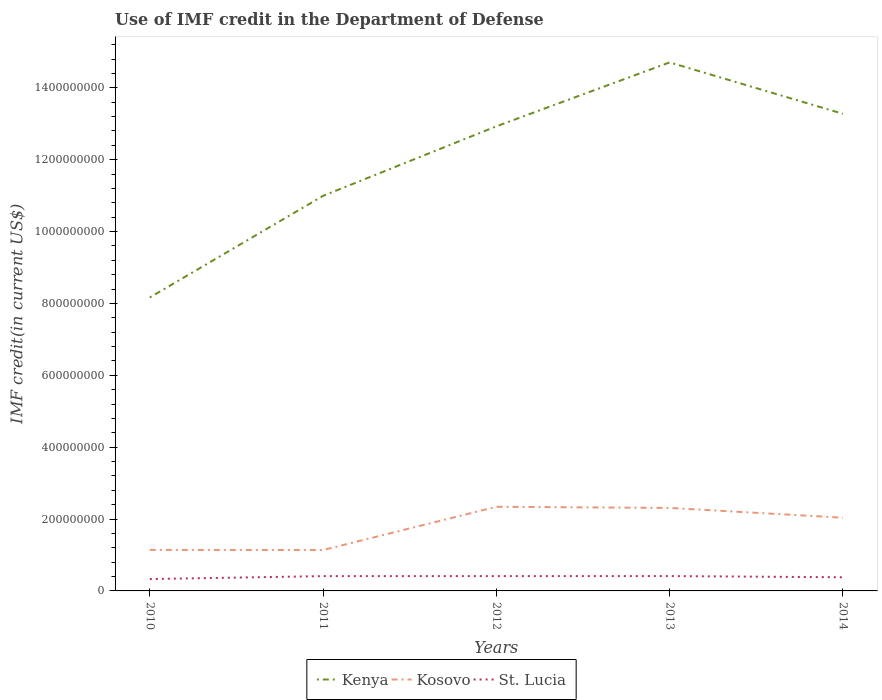How many different coloured lines are there?
Ensure brevity in your answer.  3. Is the number of lines equal to the number of legend labels?
Offer a terse response. Yes. Across all years, what is the maximum IMF credit in the Department of Defense in St. Lucia?
Provide a short and direct response. 3.30e+07. What is the total IMF credit in the Department of Defense in St. Lucia in the graph?
Give a very brief answer. 3.15e+06. What is the difference between the highest and the second highest IMF credit in the Department of Defense in St. Lucia?
Offer a very short reply. 8.25e+06. How many years are there in the graph?
Your answer should be very brief. 5. Does the graph contain any zero values?
Provide a succinct answer. No. Does the graph contain grids?
Ensure brevity in your answer.  No. What is the title of the graph?
Your answer should be compact. Use of IMF credit in the Department of Defense. Does "Samoa" appear as one of the legend labels in the graph?
Make the answer very short. No. What is the label or title of the Y-axis?
Provide a short and direct response. IMF credit(in current US$). What is the IMF credit(in current US$) in Kenya in 2010?
Keep it short and to the point. 8.17e+08. What is the IMF credit(in current US$) of Kosovo in 2010?
Your response must be concise. 1.14e+08. What is the IMF credit(in current US$) in St. Lucia in 2010?
Your answer should be compact. 3.30e+07. What is the IMF credit(in current US$) in Kenya in 2011?
Offer a very short reply. 1.10e+09. What is the IMF credit(in current US$) in Kosovo in 2011?
Make the answer very short. 1.14e+08. What is the IMF credit(in current US$) of St. Lucia in 2011?
Ensure brevity in your answer.  4.12e+07. What is the IMF credit(in current US$) in Kenya in 2012?
Give a very brief answer. 1.29e+09. What is the IMF credit(in current US$) in Kosovo in 2012?
Provide a short and direct response. 2.34e+08. What is the IMF credit(in current US$) in St. Lucia in 2012?
Offer a very short reply. 4.12e+07. What is the IMF credit(in current US$) of Kenya in 2013?
Provide a succinct answer. 1.47e+09. What is the IMF credit(in current US$) of Kosovo in 2013?
Provide a short and direct response. 2.31e+08. What is the IMF credit(in current US$) of St. Lucia in 2013?
Your response must be concise. 4.13e+07. What is the IMF credit(in current US$) of Kenya in 2014?
Offer a very short reply. 1.33e+09. What is the IMF credit(in current US$) of Kosovo in 2014?
Your answer should be very brief. 2.04e+08. What is the IMF credit(in current US$) of St. Lucia in 2014?
Ensure brevity in your answer.  3.80e+07. Across all years, what is the maximum IMF credit(in current US$) of Kenya?
Keep it short and to the point. 1.47e+09. Across all years, what is the maximum IMF credit(in current US$) of Kosovo?
Keep it short and to the point. 2.34e+08. Across all years, what is the maximum IMF credit(in current US$) in St. Lucia?
Provide a succinct answer. 4.13e+07. Across all years, what is the minimum IMF credit(in current US$) in Kenya?
Ensure brevity in your answer.  8.17e+08. Across all years, what is the minimum IMF credit(in current US$) of Kosovo?
Make the answer very short. 1.14e+08. Across all years, what is the minimum IMF credit(in current US$) of St. Lucia?
Offer a very short reply. 3.30e+07. What is the total IMF credit(in current US$) of Kenya in the graph?
Your answer should be very brief. 6.01e+09. What is the total IMF credit(in current US$) in Kosovo in the graph?
Make the answer very short. 8.97e+08. What is the total IMF credit(in current US$) in St. Lucia in the graph?
Provide a succinct answer. 1.95e+08. What is the difference between the IMF credit(in current US$) in Kenya in 2010 and that in 2011?
Offer a very short reply. -2.83e+08. What is the difference between the IMF credit(in current US$) of Kosovo in 2010 and that in 2011?
Offer a very short reply. 3.53e+05. What is the difference between the IMF credit(in current US$) in St. Lucia in 2010 and that in 2011?
Make the answer very short. -8.13e+06. What is the difference between the IMF credit(in current US$) of Kenya in 2010 and that in 2012?
Provide a succinct answer. -4.76e+08. What is the difference between the IMF credit(in current US$) in Kosovo in 2010 and that in 2012?
Your response must be concise. -1.20e+08. What is the difference between the IMF credit(in current US$) of St. Lucia in 2010 and that in 2012?
Offer a terse response. -8.17e+06. What is the difference between the IMF credit(in current US$) of Kenya in 2010 and that in 2013?
Offer a very short reply. -6.54e+08. What is the difference between the IMF credit(in current US$) in Kosovo in 2010 and that in 2013?
Offer a very short reply. -1.17e+08. What is the difference between the IMF credit(in current US$) of St. Lucia in 2010 and that in 2013?
Your response must be concise. -8.25e+06. What is the difference between the IMF credit(in current US$) in Kenya in 2010 and that in 2014?
Provide a succinct answer. -5.11e+08. What is the difference between the IMF credit(in current US$) in Kosovo in 2010 and that in 2014?
Offer a terse response. -8.96e+07. What is the difference between the IMF credit(in current US$) of St. Lucia in 2010 and that in 2014?
Keep it short and to the point. -4.98e+06. What is the difference between the IMF credit(in current US$) in Kenya in 2011 and that in 2012?
Keep it short and to the point. -1.93e+08. What is the difference between the IMF credit(in current US$) of Kosovo in 2011 and that in 2012?
Offer a terse response. -1.20e+08. What is the difference between the IMF credit(in current US$) in St. Lucia in 2011 and that in 2012?
Offer a very short reply. -4.40e+04. What is the difference between the IMF credit(in current US$) of Kenya in 2011 and that in 2013?
Provide a short and direct response. -3.71e+08. What is the difference between the IMF credit(in current US$) of Kosovo in 2011 and that in 2013?
Your answer should be compact. -1.17e+08. What is the difference between the IMF credit(in current US$) in St. Lucia in 2011 and that in 2013?
Offer a very short reply. -1.27e+05. What is the difference between the IMF credit(in current US$) in Kenya in 2011 and that in 2014?
Offer a terse response. -2.28e+08. What is the difference between the IMF credit(in current US$) of Kosovo in 2011 and that in 2014?
Offer a terse response. -8.99e+07. What is the difference between the IMF credit(in current US$) in St. Lucia in 2011 and that in 2014?
Offer a very short reply. 3.15e+06. What is the difference between the IMF credit(in current US$) in Kenya in 2012 and that in 2013?
Your response must be concise. -1.78e+08. What is the difference between the IMF credit(in current US$) of Kosovo in 2012 and that in 2013?
Ensure brevity in your answer.  3.14e+06. What is the difference between the IMF credit(in current US$) of St. Lucia in 2012 and that in 2013?
Your answer should be very brief. -8.30e+04. What is the difference between the IMF credit(in current US$) of Kenya in 2012 and that in 2014?
Your answer should be very brief. -3.49e+07. What is the difference between the IMF credit(in current US$) in Kosovo in 2012 and that in 2014?
Provide a succinct answer. 3.04e+07. What is the difference between the IMF credit(in current US$) of St. Lucia in 2012 and that in 2014?
Keep it short and to the point. 3.19e+06. What is the difference between the IMF credit(in current US$) of Kenya in 2013 and that in 2014?
Your response must be concise. 1.43e+08. What is the difference between the IMF credit(in current US$) of Kosovo in 2013 and that in 2014?
Make the answer very short. 2.73e+07. What is the difference between the IMF credit(in current US$) in St. Lucia in 2013 and that in 2014?
Provide a short and direct response. 3.28e+06. What is the difference between the IMF credit(in current US$) in Kenya in 2010 and the IMF credit(in current US$) in Kosovo in 2011?
Your answer should be compact. 7.03e+08. What is the difference between the IMF credit(in current US$) in Kenya in 2010 and the IMF credit(in current US$) in St. Lucia in 2011?
Keep it short and to the point. 7.76e+08. What is the difference between the IMF credit(in current US$) of Kosovo in 2010 and the IMF credit(in current US$) of St. Lucia in 2011?
Provide a succinct answer. 7.30e+07. What is the difference between the IMF credit(in current US$) in Kenya in 2010 and the IMF credit(in current US$) in Kosovo in 2012?
Your answer should be very brief. 5.83e+08. What is the difference between the IMF credit(in current US$) of Kenya in 2010 and the IMF credit(in current US$) of St. Lucia in 2012?
Give a very brief answer. 7.76e+08. What is the difference between the IMF credit(in current US$) of Kosovo in 2010 and the IMF credit(in current US$) of St. Lucia in 2012?
Make the answer very short. 7.29e+07. What is the difference between the IMF credit(in current US$) of Kenya in 2010 and the IMF credit(in current US$) of Kosovo in 2013?
Your answer should be compact. 5.86e+08. What is the difference between the IMF credit(in current US$) of Kenya in 2010 and the IMF credit(in current US$) of St. Lucia in 2013?
Provide a succinct answer. 7.75e+08. What is the difference between the IMF credit(in current US$) of Kosovo in 2010 and the IMF credit(in current US$) of St. Lucia in 2013?
Offer a very short reply. 7.29e+07. What is the difference between the IMF credit(in current US$) of Kenya in 2010 and the IMF credit(in current US$) of Kosovo in 2014?
Offer a very short reply. 6.13e+08. What is the difference between the IMF credit(in current US$) in Kenya in 2010 and the IMF credit(in current US$) in St. Lucia in 2014?
Offer a terse response. 7.79e+08. What is the difference between the IMF credit(in current US$) in Kosovo in 2010 and the IMF credit(in current US$) in St. Lucia in 2014?
Your response must be concise. 7.61e+07. What is the difference between the IMF credit(in current US$) of Kenya in 2011 and the IMF credit(in current US$) of Kosovo in 2012?
Provide a succinct answer. 8.65e+08. What is the difference between the IMF credit(in current US$) in Kenya in 2011 and the IMF credit(in current US$) in St. Lucia in 2012?
Give a very brief answer. 1.06e+09. What is the difference between the IMF credit(in current US$) of Kosovo in 2011 and the IMF credit(in current US$) of St. Lucia in 2012?
Provide a succinct answer. 7.26e+07. What is the difference between the IMF credit(in current US$) of Kenya in 2011 and the IMF credit(in current US$) of Kosovo in 2013?
Your answer should be very brief. 8.69e+08. What is the difference between the IMF credit(in current US$) of Kenya in 2011 and the IMF credit(in current US$) of St. Lucia in 2013?
Provide a succinct answer. 1.06e+09. What is the difference between the IMF credit(in current US$) of Kosovo in 2011 and the IMF credit(in current US$) of St. Lucia in 2013?
Offer a terse response. 7.25e+07. What is the difference between the IMF credit(in current US$) in Kenya in 2011 and the IMF credit(in current US$) in Kosovo in 2014?
Give a very brief answer. 8.96e+08. What is the difference between the IMF credit(in current US$) in Kenya in 2011 and the IMF credit(in current US$) in St. Lucia in 2014?
Your answer should be compact. 1.06e+09. What is the difference between the IMF credit(in current US$) of Kosovo in 2011 and the IMF credit(in current US$) of St. Lucia in 2014?
Ensure brevity in your answer.  7.58e+07. What is the difference between the IMF credit(in current US$) in Kenya in 2012 and the IMF credit(in current US$) in Kosovo in 2013?
Provide a succinct answer. 1.06e+09. What is the difference between the IMF credit(in current US$) in Kenya in 2012 and the IMF credit(in current US$) in St. Lucia in 2013?
Your answer should be very brief. 1.25e+09. What is the difference between the IMF credit(in current US$) in Kosovo in 2012 and the IMF credit(in current US$) in St. Lucia in 2013?
Your answer should be compact. 1.93e+08. What is the difference between the IMF credit(in current US$) of Kenya in 2012 and the IMF credit(in current US$) of Kosovo in 2014?
Provide a short and direct response. 1.09e+09. What is the difference between the IMF credit(in current US$) in Kenya in 2012 and the IMF credit(in current US$) in St. Lucia in 2014?
Keep it short and to the point. 1.25e+09. What is the difference between the IMF credit(in current US$) in Kosovo in 2012 and the IMF credit(in current US$) in St. Lucia in 2014?
Ensure brevity in your answer.  1.96e+08. What is the difference between the IMF credit(in current US$) of Kenya in 2013 and the IMF credit(in current US$) of Kosovo in 2014?
Offer a terse response. 1.27e+09. What is the difference between the IMF credit(in current US$) in Kenya in 2013 and the IMF credit(in current US$) in St. Lucia in 2014?
Give a very brief answer. 1.43e+09. What is the difference between the IMF credit(in current US$) of Kosovo in 2013 and the IMF credit(in current US$) of St. Lucia in 2014?
Provide a short and direct response. 1.93e+08. What is the average IMF credit(in current US$) of Kenya per year?
Ensure brevity in your answer.  1.20e+09. What is the average IMF credit(in current US$) in Kosovo per year?
Provide a short and direct response. 1.79e+08. What is the average IMF credit(in current US$) in St. Lucia per year?
Keep it short and to the point. 3.89e+07. In the year 2010, what is the difference between the IMF credit(in current US$) of Kenya and IMF credit(in current US$) of Kosovo?
Provide a short and direct response. 7.03e+08. In the year 2010, what is the difference between the IMF credit(in current US$) of Kenya and IMF credit(in current US$) of St. Lucia?
Offer a very short reply. 7.84e+08. In the year 2010, what is the difference between the IMF credit(in current US$) of Kosovo and IMF credit(in current US$) of St. Lucia?
Your response must be concise. 8.11e+07. In the year 2011, what is the difference between the IMF credit(in current US$) of Kenya and IMF credit(in current US$) of Kosovo?
Ensure brevity in your answer.  9.86e+08. In the year 2011, what is the difference between the IMF credit(in current US$) in Kenya and IMF credit(in current US$) in St. Lucia?
Your response must be concise. 1.06e+09. In the year 2011, what is the difference between the IMF credit(in current US$) in Kosovo and IMF credit(in current US$) in St. Lucia?
Offer a very short reply. 7.26e+07. In the year 2012, what is the difference between the IMF credit(in current US$) of Kenya and IMF credit(in current US$) of Kosovo?
Your answer should be compact. 1.06e+09. In the year 2012, what is the difference between the IMF credit(in current US$) in Kenya and IMF credit(in current US$) in St. Lucia?
Provide a succinct answer. 1.25e+09. In the year 2012, what is the difference between the IMF credit(in current US$) of Kosovo and IMF credit(in current US$) of St. Lucia?
Keep it short and to the point. 1.93e+08. In the year 2013, what is the difference between the IMF credit(in current US$) in Kenya and IMF credit(in current US$) in Kosovo?
Keep it short and to the point. 1.24e+09. In the year 2013, what is the difference between the IMF credit(in current US$) in Kenya and IMF credit(in current US$) in St. Lucia?
Make the answer very short. 1.43e+09. In the year 2013, what is the difference between the IMF credit(in current US$) of Kosovo and IMF credit(in current US$) of St. Lucia?
Provide a succinct answer. 1.90e+08. In the year 2014, what is the difference between the IMF credit(in current US$) of Kenya and IMF credit(in current US$) of Kosovo?
Give a very brief answer. 1.12e+09. In the year 2014, what is the difference between the IMF credit(in current US$) in Kenya and IMF credit(in current US$) in St. Lucia?
Your response must be concise. 1.29e+09. In the year 2014, what is the difference between the IMF credit(in current US$) in Kosovo and IMF credit(in current US$) in St. Lucia?
Provide a short and direct response. 1.66e+08. What is the ratio of the IMF credit(in current US$) in Kenya in 2010 to that in 2011?
Your answer should be very brief. 0.74. What is the ratio of the IMF credit(in current US$) in Kosovo in 2010 to that in 2011?
Ensure brevity in your answer.  1. What is the ratio of the IMF credit(in current US$) in St. Lucia in 2010 to that in 2011?
Your answer should be compact. 0.8. What is the ratio of the IMF credit(in current US$) in Kenya in 2010 to that in 2012?
Your answer should be very brief. 0.63. What is the ratio of the IMF credit(in current US$) in Kosovo in 2010 to that in 2012?
Provide a short and direct response. 0.49. What is the ratio of the IMF credit(in current US$) of St. Lucia in 2010 to that in 2012?
Make the answer very short. 0.8. What is the ratio of the IMF credit(in current US$) in Kenya in 2010 to that in 2013?
Offer a terse response. 0.56. What is the ratio of the IMF credit(in current US$) in Kosovo in 2010 to that in 2013?
Make the answer very short. 0.49. What is the ratio of the IMF credit(in current US$) in St. Lucia in 2010 to that in 2013?
Offer a terse response. 0.8. What is the ratio of the IMF credit(in current US$) of Kenya in 2010 to that in 2014?
Offer a terse response. 0.62. What is the ratio of the IMF credit(in current US$) of Kosovo in 2010 to that in 2014?
Your answer should be very brief. 0.56. What is the ratio of the IMF credit(in current US$) in St. Lucia in 2010 to that in 2014?
Offer a very short reply. 0.87. What is the ratio of the IMF credit(in current US$) of Kenya in 2011 to that in 2012?
Give a very brief answer. 0.85. What is the ratio of the IMF credit(in current US$) in Kosovo in 2011 to that in 2012?
Offer a very short reply. 0.49. What is the ratio of the IMF credit(in current US$) in St. Lucia in 2011 to that in 2012?
Offer a terse response. 1. What is the ratio of the IMF credit(in current US$) in Kenya in 2011 to that in 2013?
Your answer should be compact. 0.75. What is the ratio of the IMF credit(in current US$) of Kosovo in 2011 to that in 2013?
Provide a succinct answer. 0.49. What is the ratio of the IMF credit(in current US$) in Kenya in 2011 to that in 2014?
Your answer should be compact. 0.83. What is the ratio of the IMF credit(in current US$) of Kosovo in 2011 to that in 2014?
Keep it short and to the point. 0.56. What is the ratio of the IMF credit(in current US$) of St. Lucia in 2011 to that in 2014?
Give a very brief answer. 1.08. What is the ratio of the IMF credit(in current US$) of Kenya in 2012 to that in 2013?
Make the answer very short. 0.88. What is the ratio of the IMF credit(in current US$) in Kosovo in 2012 to that in 2013?
Keep it short and to the point. 1.01. What is the ratio of the IMF credit(in current US$) in Kenya in 2012 to that in 2014?
Your response must be concise. 0.97. What is the ratio of the IMF credit(in current US$) in Kosovo in 2012 to that in 2014?
Your response must be concise. 1.15. What is the ratio of the IMF credit(in current US$) in St. Lucia in 2012 to that in 2014?
Your response must be concise. 1.08. What is the ratio of the IMF credit(in current US$) in Kenya in 2013 to that in 2014?
Keep it short and to the point. 1.11. What is the ratio of the IMF credit(in current US$) of Kosovo in 2013 to that in 2014?
Your response must be concise. 1.13. What is the ratio of the IMF credit(in current US$) of St. Lucia in 2013 to that in 2014?
Provide a succinct answer. 1.09. What is the difference between the highest and the second highest IMF credit(in current US$) of Kenya?
Keep it short and to the point. 1.43e+08. What is the difference between the highest and the second highest IMF credit(in current US$) of Kosovo?
Your response must be concise. 3.14e+06. What is the difference between the highest and the second highest IMF credit(in current US$) in St. Lucia?
Your answer should be very brief. 8.30e+04. What is the difference between the highest and the lowest IMF credit(in current US$) of Kenya?
Give a very brief answer. 6.54e+08. What is the difference between the highest and the lowest IMF credit(in current US$) of Kosovo?
Keep it short and to the point. 1.20e+08. What is the difference between the highest and the lowest IMF credit(in current US$) of St. Lucia?
Your answer should be very brief. 8.25e+06. 